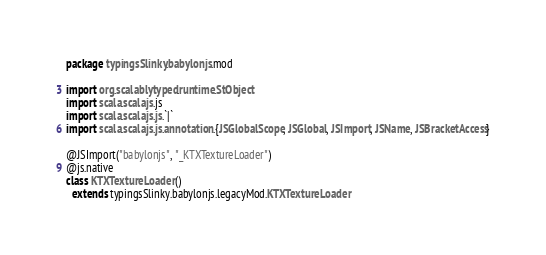Convert code to text. <code><loc_0><loc_0><loc_500><loc_500><_Scala_>package typingsSlinky.babylonjs.mod

import org.scalablytyped.runtime.StObject
import scala.scalajs.js
import scala.scalajs.js.`|`
import scala.scalajs.js.annotation.{JSGlobalScope, JSGlobal, JSImport, JSName, JSBracketAccess}

@JSImport("babylonjs", "_KTXTextureLoader")
@js.native
class KTXTextureLoader ()
  extends typingsSlinky.babylonjs.legacyMod.KTXTextureLoader
</code> 